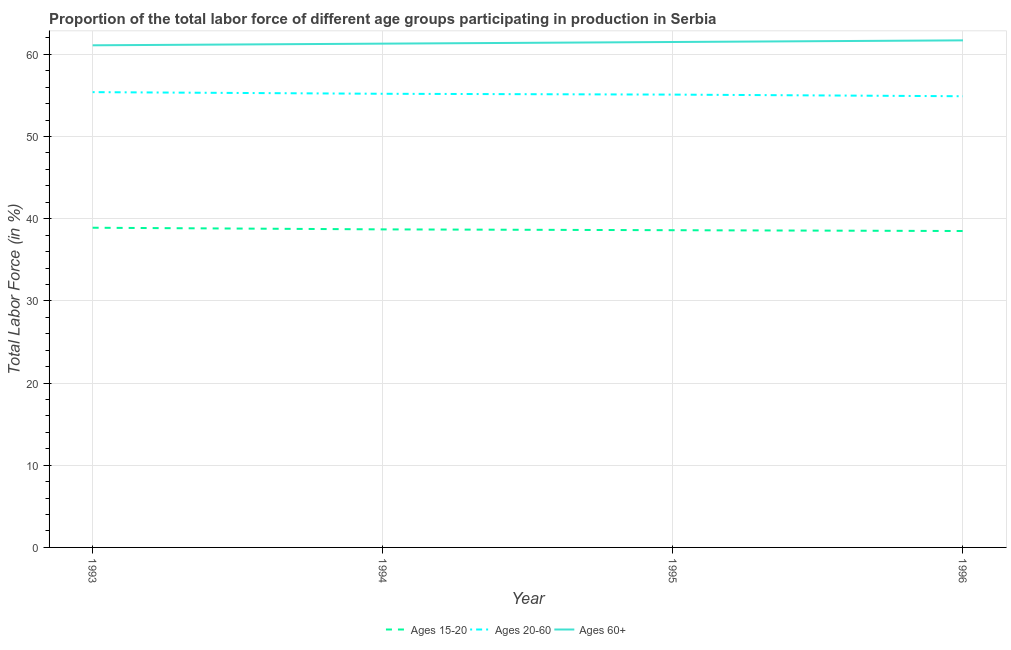Does the line corresponding to percentage of labor force within the age group 15-20 intersect with the line corresponding to percentage of labor force above age 60?
Offer a very short reply. No. Is the number of lines equal to the number of legend labels?
Give a very brief answer. Yes. What is the percentage of labor force within the age group 20-60 in 1996?
Provide a short and direct response. 54.9. Across all years, what is the maximum percentage of labor force above age 60?
Make the answer very short. 61.7. Across all years, what is the minimum percentage of labor force above age 60?
Your answer should be compact. 61.1. In which year was the percentage of labor force above age 60 minimum?
Offer a terse response. 1993. What is the total percentage of labor force within the age group 20-60 in the graph?
Provide a short and direct response. 220.6. What is the difference between the percentage of labor force within the age group 15-20 in 1995 and that in 1996?
Make the answer very short. 0.1. What is the difference between the percentage of labor force within the age group 20-60 in 1995 and the percentage of labor force within the age group 15-20 in 1996?
Ensure brevity in your answer.  16.6. What is the average percentage of labor force within the age group 20-60 per year?
Your response must be concise. 55.15. In the year 1996, what is the difference between the percentage of labor force above age 60 and percentage of labor force within the age group 15-20?
Your answer should be very brief. 23.2. What is the ratio of the percentage of labor force above age 60 in 1993 to that in 1995?
Ensure brevity in your answer.  0.99. What is the difference between the highest and the second highest percentage of labor force within the age group 20-60?
Make the answer very short. 0.2. What is the difference between the highest and the lowest percentage of labor force within the age group 15-20?
Your response must be concise. 0.4. In how many years, is the percentage of labor force above age 60 greater than the average percentage of labor force above age 60 taken over all years?
Your answer should be compact. 2. Is the percentage of labor force within the age group 20-60 strictly greater than the percentage of labor force within the age group 15-20 over the years?
Your answer should be very brief. Yes. Is the percentage of labor force within the age group 20-60 strictly less than the percentage of labor force above age 60 over the years?
Give a very brief answer. Yes. How many years are there in the graph?
Offer a very short reply. 4. Are the values on the major ticks of Y-axis written in scientific E-notation?
Your answer should be compact. No. Does the graph contain any zero values?
Give a very brief answer. No. Does the graph contain grids?
Keep it short and to the point. Yes. Where does the legend appear in the graph?
Provide a short and direct response. Bottom center. How are the legend labels stacked?
Give a very brief answer. Horizontal. What is the title of the graph?
Ensure brevity in your answer.  Proportion of the total labor force of different age groups participating in production in Serbia. Does "Food" appear as one of the legend labels in the graph?
Your answer should be very brief. No. What is the label or title of the Y-axis?
Your answer should be compact. Total Labor Force (in %). What is the Total Labor Force (in %) of Ages 15-20 in 1993?
Offer a very short reply. 38.9. What is the Total Labor Force (in %) of Ages 20-60 in 1993?
Your answer should be very brief. 55.4. What is the Total Labor Force (in %) in Ages 60+ in 1993?
Give a very brief answer. 61.1. What is the Total Labor Force (in %) of Ages 15-20 in 1994?
Your answer should be very brief. 38.7. What is the Total Labor Force (in %) of Ages 20-60 in 1994?
Make the answer very short. 55.2. What is the Total Labor Force (in %) of Ages 60+ in 1994?
Offer a terse response. 61.3. What is the Total Labor Force (in %) in Ages 15-20 in 1995?
Offer a terse response. 38.6. What is the Total Labor Force (in %) in Ages 20-60 in 1995?
Your response must be concise. 55.1. What is the Total Labor Force (in %) of Ages 60+ in 1995?
Your response must be concise. 61.5. What is the Total Labor Force (in %) in Ages 15-20 in 1996?
Make the answer very short. 38.5. What is the Total Labor Force (in %) of Ages 20-60 in 1996?
Ensure brevity in your answer.  54.9. What is the Total Labor Force (in %) in Ages 60+ in 1996?
Provide a succinct answer. 61.7. Across all years, what is the maximum Total Labor Force (in %) in Ages 15-20?
Provide a succinct answer. 38.9. Across all years, what is the maximum Total Labor Force (in %) of Ages 20-60?
Your answer should be compact. 55.4. Across all years, what is the maximum Total Labor Force (in %) in Ages 60+?
Provide a short and direct response. 61.7. Across all years, what is the minimum Total Labor Force (in %) in Ages 15-20?
Your answer should be very brief. 38.5. Across all years, what is the minimum Total Labor Force (in %) in Ages 20-60?
Provide a succinct answer. 54.9. Across all years, what is the minimum Total Labor Force (in %) in Ages 60+?
Provide a succinct answer. 61.1. What is the total Total Labor Force (in %) in Ages 15-20 in the graph?
Provide a short and direct response. 154.7. What is the total Total Labor Force (in %) in Ages 20-60 in the graph?
Your answer should be very brief. 220.6. What is the total Total Labor Force (in %) of Ages 60+ in the graph?
Ensure brevity in your answer.  245.6. What is the difference between the Total Labor Force (in %) of Ages 15-20 in 1993 and that in 1994?
Give a very brief answer. 0.2. What is the difference between the Total Labor Force (in %) in Ages 60+ in 1993 and that in 1994?
Offer a very short reply. -0.2. What is the difference between the Total Labor Force (in %) in Ages 15-20 in 1993 and that in 1995?
Your answer should be very brief. 0.3. What is the difference between the Total Labor Force (in %) in Ages 20-60 in 1993 and that in 1995?
Your answer should be compact. 0.3. What is the difference between the Total Labor Force (in %) in Ages 15-20 in 1993 and that in 1996?
Your answer should be compact. 0.4. What is the difference between the Total Labor Force (in %) of Ages 20-60 in 1993 and that in 1996?
Your response must be concise. 0.5. What is the difference between the Total Labor Force (in %) in Ages 60+ in 1993 and that in 1996?
Provide a succinct answer. -0.6. What is the difference between the Total Labor Force (in %) in Ages 15-20 in 1994 and that in 1996?
Offer a very short reply. 0.2. What is the difference between the Total Labor Force (in %) of Ages 20-60 in 1994 and that in 1996?
Ensure brevity in your answer.  0.3. What is the difference between the Total Labor Force (in %) of Ages 15-20 in 1995 and that in 1996?
Give a very brief answer. 0.1. What is the difference between the Total Labor Force (in %) of Ages 60+ in 1995 and that in 1996?
Make the answer very short. -0.2. What is the difference between the Total Labor Force (in %) of Ages 15-20 in 1993 and the Total Labor Force (in %) of Ages 20-60 in 1994?
Make the answer very short. -16.3. What is the difference between the Total Labor Force (in %) of Ages 15-20 in 1993 and the Total Labor Force (in %) of Ages 60+ in 1994?
Provide a short and direct response. -22.4. What is the difference between the Total Labor Force (in %) in Ages 15-20 in 1993 and the Total Labor Force (in %) in Ages 20-60 in 1995?
Provide a succinct answer. -16.2. What is the difference between the Total Labor Force (in %) of Ages 15-20 in 1993 and the Total Labor Force (in %) of Ages 60+ in 1995?
Your answer should be very brief. -22.6. What is the difference between the Total Labor Force (in %) in Ages 20-60 in 1993 and the Total Labor Force (in %) in Ages 60+ in 1995?
Your answer should be compact. -6.1. What is the difference between the Total Labor Force (in %) in Ages 15-20 in 1993 and the Total Labor Force (in %) in Ages 20-60 in 1996?
Provide a succinct answer. -16. What is the difference between the Total Labor Force (in %) of Ages 15-20 in 1993 and the Total Labor Force (in %) of Ages 60+ in 1996?
Ensure brevity in your answer.  -22.8. What is the difference between the Total Labor Force (in %) of Ages 15-20 in 1994 and the Total Labor Force (in %) of Ages 20-60 in 1995?
Your response must be concise. -16.4. What is the difference between the Total Labor Force (in %) in Ages 15-20 in 1994 and the Total Labor Force (in %) in Ages 60+ in 1995?
Ensure brevity in your answer.  -22.8. What is the difference between the Total Labor Force (in %) of Ages 15-20 in 1994 and the Total Labor Force (in %) of Ages 20-60 in 1996?
Ensure brevity in your answer.  -16.2. What is the difference between the Total Labor Force (in %) of Ages 15-20 in 1995 and the Total Labor Force (in %) of Ages 20-60 in 1996?
Offer a terse response. -16.3. What is the difference between the Total Labor Force (in %) in Ages 15-20 in 1995 and the Total Labor Force (in %) in Ages 60+ in 1996?
Ensure brevity in your answer.  -23.1. What is the difference between the Total Labor Force (in %) in Ages 20-60 in 1995 and the Total Labor Force (in %) in Ages 60+ in 1996?
Your response must be concise. -6.6. What is the average Total Labor Force (in %) of Ages 15-20 per year?
Your answer should be very brief. 38.67. What is the average Total Labor Force (in %) in Ages 20-60 per year?
Make the answer very short. 55.15. What is the average Total Labor Force (in %) in Ages 60+ per year?
Keep it short and to the point. 61.4. In the year 1993, what is the difference between the Total Labor Force (in %) in Ages 15-20 and Total Labor Force (in %) in Ages 20-60?
Your answer should be very brief. -16.5. In the year 1993, what is the difference between the Total Labor Force (in %) in Ages 15-20 and Total Labor Force (in %) in Ages 60+?
Provide a succinct answer. -22.2. In the year 1994, what is the difference between the Total Labor Force (in %) of Ages 15-20 and Total Labor Force (in %) of Ages 20-60?
Provide a succinct answer. -16.5. In the year 1994, what is the difference between the Total Labor Force (in %) in Ages 15-20 and Total Labor Force (in %) in Ages 60+?
Make the answer very short. -22.6. In the year 1995, what is the difference between the Total Labor Force (in %) of Ages 15-20 and Total Labor Force (in %) of Ages 20-60?
Make the answer very short. -16.5. In the year 1995, what is the difference between the Total Labor Force (in %) in Ages 15-20 and Total Labor Force (in %) in Ages 60+?
Keep it short and to the point. -22.9. In the year 1995, what is the difference between the Total Labor Force (in %) in Ages 20-60 and Total Labor Force (in %) in Ages 60+?
Give a very brief answer. -6.4. In the year 1996, what is the difference between the Total Labor Force (in %) of Ages 15-20 and Total Labor Force (in %) of Ages 20-60?
Your answer should be compact. -16.4. In the year 1996, what is the difference between the Total Labor Force (in %) in Ages 15-20 and Total Labor Force (in %) in Ages 60+?
Your answer should be very brief. -23.2. In the year 1996, what is the difference between the Total Labor Force (in %) in Ages 20-60 and Total Labor Force (in %) in Ages 60+?
Give a very brief answer. -6.8. What is the ratio of the Total Labor Force (in %) in Ages 15-20 in 1993 to that in 1994?
Your response must be concise. 1.01. What is the ratio of the Total Labor Force (in %) of Ages 20-60 in 1993 to that in 1994?
Give a very brief answer. 1. What is the ratio of the Total Labor Force (in %) of Ages 15-20 in 1993 to that in 1995?
Provide a short and direct response. 1.01. What is the ratio of the Total Labor Force (in %) in Ages 20-60 in 1993 to that in 1995?
Keep it short and to the point. 1.01. What is the ratio of the Total Labor Force (in %) in Ages 15-20 in 1993 to that in 1996?
Offer a terse response. 1.01. What is the ratio of the Total Labor Force (in %) of Ages 20-60 in 1993 to that in 1996?
Keep it short and to the point. 1.01. What is the ratio of the Total Labor Force (in %) of Ages 60+ in 1993 to that in 1996?
Offer a very short reply. 0.99. What is the ratio of the Total Labor Force (in %) in Ages 20-60 in 1994 to that in 1995?
Your answer should be very brief. 1. What is the ratio of the Total Labor Force (in %) in Ages 15-20 in 1994 to that in 1996?
Your response must be concise. 1.01. What is the ratio of the Total Labor Force (in %) in Ages 60+ in 1994 to that in 1996?
Keep it short and to the point. 0.99. What is the ratio of the Total Labor Force (in %) of Ages 15-20 in 1995 to that in 1996?
Your response must be concise. 1. What is the ratio of the Total Labor Force (in %) in Ages 20-60 in 1995 to that in 1996?
Offer a terse response. 1. What is the difference between the highest and the second highest Total Labor Force (in %) of Ages 60+?
Ensure brevity in your answer.  0.2. What is the difference between the highest and the lowest Total Labor Force (in %) in Ages 20-60?
Offer a very short reply. 0.5. What is the difference between the highest and the lowest Total Labor Force (in %) of Ages 60+?
Your answer should be compact. 0.6. 